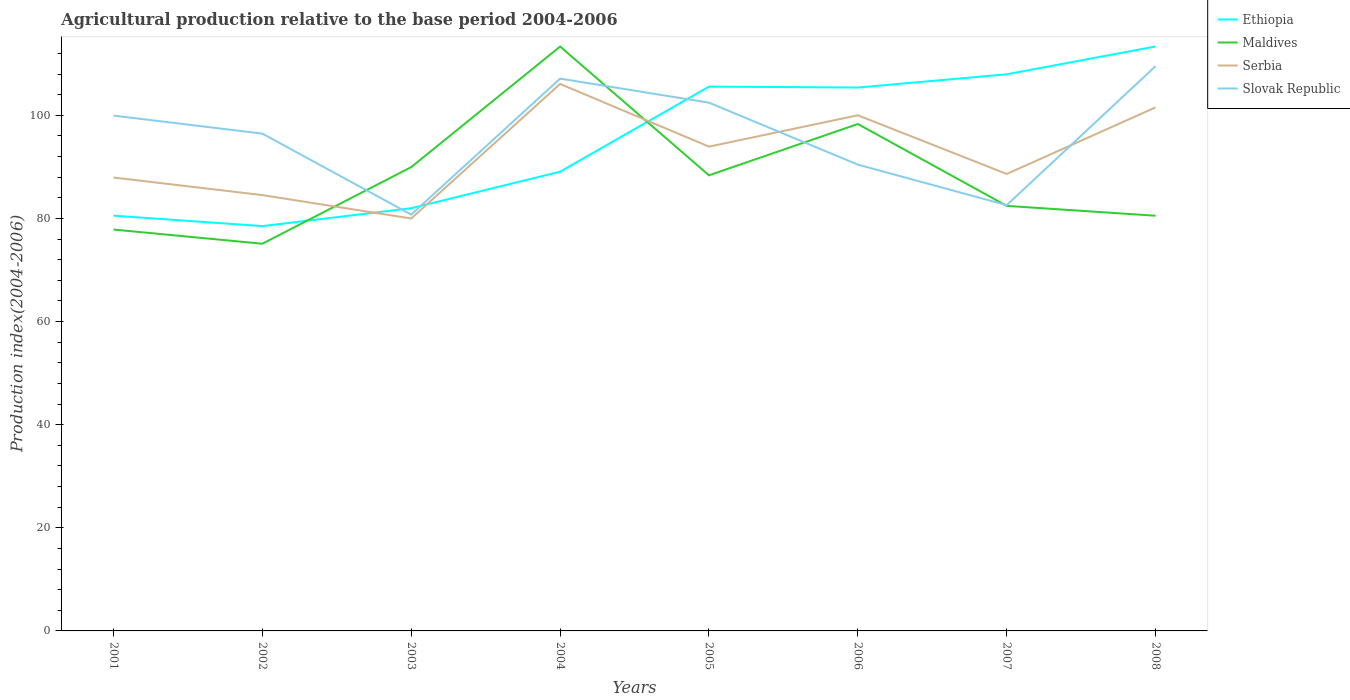How many different coloured lines are there?
Keep it short and to the point. 4. Across all years, what is the maximum agricultural production index in Slovak Republic?
Give a very brief answer. 80.74. What is the total agricultural production index in Ethiopia in the graph?
Keep it short and to the point. -24.29. What is the difference between the highest and the second highest agricultural production index in Ethiopia?
Provide a succinct answer. 34.84. Is the agricultural production index in Maldives strictly greater than the agricultural production index in Ethiopia over the years?
Make the answer very short. No. How many years are there in the graph?
Keep it short and to the point. 8. Does the graph contain grids?
Make the answer very short. No. Where does the legend appear in the graph?
Your response must be concise. Top right. How many legend labels are there?
Provide a short and direct response. 4. How are the legend labels stacked?
Make the answer very short. Vertical. What is the title of the graph?
Keep it short and to the point. Agricultural production relative to the base period 2004-2006. What is the label or title of the Y-axis?
Provide a short and direct response. Production index(2004-2006). What is the Production index(2004-2006) in Ethiopia in 2001?
Provide a short and direct response. 80.53. What is the Production index(2004-2006) in Maldives in 2001?
Offer a very short reply. 77.84. What is the Production index(2004-2006) in Serbia in 2001?
Give a very brief answer. 87.93. What is the Production index(2004-2006) of Slovak Republic in 2001?
Keep it short and to the point. 99.94. What is the Production index(2004-2006) in Ethiopia in 2002?
Keep it short and to the point. 78.51. What is the Production index(2004-2006) of Maldives in 2002?
Make the answer very short. 75.09. What is the Production index(2004-2006) of Serbia in 2002?
Make the answer very short. 84.52. What is the Production index(2004-2006) in Slovak Republic in 2002?
Make the answer very short. 96.44. What is the Production index(2004-2006) in Ethiopia in 2003?
Your answer should be compact. 81.98. What is the Production index(2004-2006) in Maldives in 2003?
Give a very brief answer. 89.95. What is the Production index(2004-2006) in Serbia in 2003?
Offer a very short reply. 79.98. What is the Production index(2004-2006) of Slovak Republic in 2003?
Keep it short and to the point. 80.74. What is the Production index(2004-2006) of Ethiopia in 2004?
Offer a terse response. 89.06. What is the Production index(2004-2006) of Maldives in 2004?
Your answer should be very brief. 113.33. What is the Production index(2004-2006) in Serbia in 2004?
Your answer should be compact. 106.08. What is the Production index(2004-2006) in Slovak Republic in 2004?
Your answer should be very brief. 107.11. What is the Production index(2004-2006) in Ethiopia in 2005?
Offer a very short reply. 105.56. What is the Production index(2004-2006) in Maldives in 2005?
Provide a short and direct response. 88.36. What is the Production index(2004-2006) of Serbia in 2005?
Your answer should be compact. 93.92. What is the Production index(2004-2006) in Slovak Republic in 2005?
Your answer should be compact. 102.45. What is the Production index(2004-2006) of Ethiopia in 2006?
Your answer should be compact. 105.38. What is the Production index(2004-2006) in Maldives in 2006?
Your response must be concise. 98.31. What is the Production index(2004-2006) in Slovak Republic in 2006?
Give a very brief answer. 90.43. What is the Production index(2004-2006) of Ethiopia in 2007?
Your response must be concise. 107.95. What is the Production index(2004-2006) of Maldives in 2007?
Keep it short and to the point. 82.43. What is the Production index(2004-2006) in Serbia in 2007?
Your response must be concise. 88.62. What is the Production index(2004-2006) in Slovak Republic in 2007?
Make the answer very short. 82.57. What is the Production index(2004-2006) of Ethiopia in 2008?
Give a very brief answer. 113.35. What is the Production index(2004-2006) of Maldives in 2008?
Give a very brief answer. 80.52. What is the Production index(2004-2006) in Serbia in 2008?
Provide a succinct answer. 101.53. What is the Production index(2004-2006) of Slovak Republic in 2008?
Ensure brevity in your answer.  109.53. Across all years, what is the maximum Production index(2004-2006) in Ethiopia?
Give a very brief answer. 113.35. Across all years, what is the maximum Production index(2004-2006) of Maldives?
Offer a very short reply. 113.33. Across all years, what is the maximum Production index(2004-2006) in Serbia?
Your response must be concise. 106.08. Across all years, what is the maximum Production index(2004-2006) of Slovak Republic?
Offer a very short reply. 109.53. Across all years, what is the minimum Production index(2004-2006) in Ethiopia?
Offer a terse response. 78.51. Across all years, what is the minimum Production index(2004-2006) in Maldives?
Make the answer very short. 75.09. Across all years, what is the minimum Production index(2004-2006) in Serbia?
Offer a very short reply. 79.98. Across all years, what is the minimum Production index(2004-2006) of Slovak Republic?
Your answer should be compact. 80.74. What is the total Production index(2004-2006) of Ethiopia in the graph?
Your answer should be very brief. 762.32. What is the total Production index(2004-2006) in Maldives in the graph?
Your answer should be very brief. 705.83. What is the total Production index(2004-2006) in Serbia in the graph?
Keep it short and to the point. 742.58. What is the total Production index(2004-2006) of Slovak Republic in the graph?
Give a very brief answer. 769.21. What is the difference between the Production index(2004-2006) in Ethiopia in 2001 and that in 2002?
Your answer should be compact. 2.02. What is the difference between the Production index(2004-2006) in Maldives in 2001 and that in 2002?
Offer a terse response. 2.75. What is the difference between the Production index(2004-2006) in Serbia in 2001 and that in 2002?
Your response must be concise. 3.41. What is the difference between the Production index(2004-2006) of Ethiopia in 2001 and that in 2003?
Give a very brief answer. -1.45. What is the difference between the Production index(2004-2006) in Maldives in 2001 and that in 2003?
Offer a very short reply. -12.11. What is the difference between the Production index(2004-2006) in Serbia in 2001 and that in 2003?
Your answer should be very brief. 7.95. What is the difference between the Production index(2004-2006) of Slovak Republic in 2001 and that in 2003?
Your answer should be very brief. 19.2. What is the difference between the Production index(2004-2006) in Ethiopia in 2001 and that in 2004?
Offer a terse response. -8.53. What is the difference between the Production index(2004-2006) in Maldives in 2001 and that in 2004?
Your answer should be compact. -35.49. What is the difference between the Production index(2004-2006) in Serbia in 2001 and that in 2004?
Your answer should be very brief. -18.15. What is the difference between the Production index(2004-2006) of Slovak Republic in 2001 and that in 2004?
Ensure brevity in your answer.  -7.17. What is the difference between the Production index(2004-2006) of Ethiopia in 2001 and that in 2005?
Offer a very short reply. -25.03. What is the difference between the Production index(2004-2006) of Maldives in 2001 and that in 2005?
Your answer should be compact. -10.52. What is the difference between the Production index(2004-2006) of Serbia in 2001 and that in 2005?
Keep it short and to the point. -5.99. What is the difference between the Production index(2004-2006) in Slovak Republic in 2001 and that in 2005?
Your answer should be compact. -2.51. What is the difference between the Production index(2004-2006) of Ethiopia in 2001 and that in 2006?
Your answer should be compact. -24.85. What is the difference between the Production index(2004-2006) of Maldives in 2001 and that in 2006?
Provide a succinct answer. -20.47. What is the difference between the Production index(2004-2006) in Serbia in 2001 and that in 2006?
Make the answer very short. -12.07. What is the difference between the Production index(2004-2006) of Slovak Republic in 2001 and that in 2006?
Your response must be concise. 9.51. What is the difference between the Production index(2004-2006) of Ethiopia in 2001 and that in 2007?
Provide a short and direct response. -27.42. What is the difference between the Production index(2004-2006) of Maldives in 2001 and that in 2007?
Give a very brief answer. -4.59. What is the difference between the Production index(2004-2006) in Serbia in 2001 and that in 2007?
Your response must be concise. -0.69. What is the difference between the Production index(2004-2006) in Slovak Republic in 2001 and that in 2007?
Provide a succinct answer. 17.37. What is the difference between the Production index(2004-2006) of Ethiopia in 2001 and that in 2008?
Provide a succinct answer. -32.82. What is the difference between the Production index(2004-2006) in Maldives in 2001 and that in 2008?
Ensure brevity in your answer.  -2.68. What is the difference between the Production index(2004-2006) in Serbia in 2001 and that in 2008?
Your answer should be compact. -13.6. What is the difference between the Production index(2004-2006) in Slovak Republic in 2001 and that in 2008?
Your answer should be compact. -9.59. What is the difference between the Production index(2004-2006) in Ethiopia in 2002 and that in 2003?
Your answer should be very brief. -3.47. What is the difference between the Production index(2004-2006) of Maldives in 2002 and that in 2003?
Give a very brief answer. -14.86. What is the difference between the Production index(2004-2006) in Serbia in 2002 and that in 2003?
Provide a succinct answer. 4.54. What is the difference between the Production index(2004-2006) of Slovak Republic in 2002 and that in 2003?
Your response must be concise. 15.7. What is the difference between the Production index(2004-2006) of Ethiopia in 2002 and that in 2004?
Provide a succinct answer. -10.55. What is the difference between the Production index(2004-2006) in Maldives in 2002 and that in 2004?
Give a very brief answer. -38.24. What is the difference between the Production index(2004-2006) in Serbia in 2002 and that in 2004?
Provide a succinct answer. -21.56. What is the difference between the Production index(2004-2006) of Slovak Republic in 2002 and that in 2004?
Your response must be concise. -10.67. What is the difference between the Production index(2004-2006) of Ethiopia in 2002 and that in 2005?
Ensure brevity in your answer.  -27.05. What is the difference between the Production index(2004-2006) in Maldives in 2002 and that in 2005?
Ensure brevity in your answer.  -13.27. What is the difference between the Production index(2004-2006) of Serbia in 2002 and that in 2005?
Make the answer very short. -9.4. What is the difference between the Production index(2004-2006) of Slovak Republic in 2002 and that in 2005?
Make the answer very short. -6.01. What is the difference between the Production index(2004-2006) of Ethiopia in 2002 and that in 2006?
Your answer should be compact. -26.87. What is the difference between the Production index(2004-2006) of Maldives in 2002 and that in 2006?
Offer a very short reply. -23.22. What is the difference between the Production index(2004-2006) in Serbia in 2002 and that in 2006?
Your response must be concise. -15.48. What is the difference between the Production index(2004-2006) in Slovak Republic in 2002 and that in 2006?
Your answer should be compact. 6.01. What is the difference between the Production index(2004-2006) in Ethiopia in 2002 and that in 2007?
Your answer should be very brief. -29.44. What is the difference between the Production index(2004-2006) of Maldives in 2002 and that in 2007?
Offer a terse response. -7.34. What is the difference between the Production index(2004-2006) in Serbia in 2002 and that in 2007?
Your response must be concise. -4.1. What is the difference between the Production index(2004-2006) of Slovak Republic in 2002 and that in 2007?
Make the answer very short. 13.87. What is the difference between the Production index(2004-2006) in Ethiopia in 2002 and that in 2008?
Offer a very short reply. -34.84. What is the difference between the Production index(2004-2006) in Maldives in 2002 and that in 2008?
Provide a short and direct response. -5.43. What is the difference between the Production index(2004-2006) in Serbia in 2002 and that in 2008?
Your answer should be compact. -17.01. What is the difference between the Production index(2004-2006) of Slovak Republic in 2002 and that in 2008?
Provide a succinct answer. -13.09. What is the difference between the Production index(2004-2006) of Ethiopia in 2003 and that in 2004?
Provide a succinct answer. -7.08. What is the difference between the Production index(2004-2006) of Maldives in 2003 and that in 2004?
Your answer should be very brief. -23.38. What is the difference between the Production index(2004-2006) in Serbia in 2003 and that in 2004?
Offer a terse response. -26.1. What is the difference between the Production index(2004-2006) in Slovak Republic in 2003 and that in 2004?
Ensure brevity in your answer.  -26.37. What is the difference between the Production index(2004-2006) of Ethiopia in 2003 and that in 2005?
Your answer should be compact. -23.58. What is the difference between the Production index(2004-2006) in Maldives in 2003 and that in 2005?
Ensure brevity in your answer.  1.59. What is the difference between the Production index(2004-2006) of Serbia in 2003 and that in 2005?
Make the answer very short. -13.94. What is the difference between the Production index(2004-2006) in Slovak Republic in 2003 and that in 2005?
Offer a very short reply. -21.71. What is the difference between the Production index(2004-2006) in Ethiopia in 2003 and that in 2006?
Make the answer very short. -23.4. What is the difference between the Production index(2004-2006) in Maldives in 2003 and that in 2006?
Offer a terse response. -8.36. What is the difference between the Production index(2004-2006) of Serbia in 2003 and that in 2006?
Give a very brief answer. -20.02. What is the difference between the Production index(2004-2006) in Slovak Republic in 2003 and that in 2006?
Offer a terse response. -9.69. What is the difference between the Production index(2004-2006) of Ethiopia in 2003 and that in 2007?
Your answer should be compact. -25.97. What is the difference between the Production index(2004-2006) in Maldives in 2003 and that in 2007?
Provide a succinct answer. 7.52. What is the difference between the Production index(2004-2006) of Serbia in 2003 and that in 2007?
Offer a terse response. -8.64. What is the difference between the Production index(2004-2006) of Slovak Republic in 2003 and that in 2007?
Provide a succinct answer. -1.83. What is the difference between the Production index(2004-2006) of Ethiopia in 2003 and that in 2008?
Ensure brevity in your answer.  -31.37. What is the difference between the Production index(2004-2006) in Maldives in 2003 and that in 2008?
Offer a terse response. 9.43. What is the difference between the Production index(2004-2006) in Serbia in 2003 and that in 2008?
Provide a succinct answer. -21.55. What is the difference between the Production index(2004-2006) in Slovak Republic in 2003 and that in 2008?
Your answer should be very brief. -28.79. What is the difference between the Production index(2004-2006) in Ethiopia in 2004 and that in 2005?
Make the answer very short. -16.5. What is the difference between the Production index(2004-2006) of Maldives in 2004 and that in 2005?
Ensure brevity in your answer.  24.97. What is the difference between the Production index(2004-2006) of Serbia in 2004 and that in 2005?
Give a very brief answer. 12.16. What is the difference between the Production index(2004-2006) of Slovak Republic in 2004 and that in 2005?
Ensure brevity in your answer.  4.66. What is the difference between the Production index(2004-2006) of Ethiopia in 2004 and that in 2006?
Your answer should be very brief. -16.32. What is the difference between the Production index(2004-2006) of Maldives in 2004 and that in 2006?
Make the answer very short. 15.02. What is the difference between the Production index(2004-2006) in Serbia in 2004 and that in 2006?
Provide a short and direct response. 6.08. What is the difference between the Production index(2004-2006) in Slovak Republic in 2004 and that in 2006?
Keep it short and to the point. 16.68. What is the difference between the Production index(2004-2006) of Ethiopia in 2004 and that in 2007?
Give a very brief answer. -18.89. What is the difference between the Production index(2004-2006) of Maldives in 2004 and that in 2007?
Your response must be concise. 30.9. What is the difference between the Production index(2004-2006) of Serbia in 2004 and that in 2007?
Ensure brevity in your answer.  17.46. What is the difference between the Production index(2004-2006) of Slovak Republic in 2004 and that in 2007?
Offer a very short reply. 24.54. What is the difference between the Production index(2004-2006) of Ethiopia in 2004 and that in 2008?
Provide a short and direct response. -24.29. What is the difference between the Production index(2004-2006) in Maldives in 2004 and that in 2008?
Offer a terse response. 32.81. What is the difference between the Production index(2004-2006) in Serbia in 2004 and that in 2008?
Give a very brief answer. 4.55. What is the difference between the Production index(2004-2006) in Slovak Republic in 2004 and that in 2008?
Ensure brevity in your answer.  -2.42. What is the difference between the Production index(2004-2006) of Ethiopia in 2005 and that in 2006?
Keep it short and to the point. 0.18. What is the difference between the Production index(2004-2006) in Maldives in 2005 and that in 2006?
Your answer should be compact. -9.95. What is the difference between the Production index(2004-2006) of Serbia in 2005 and that in 2006?
Your answer should be very brief. -6.08. What is the difference between the Production index(2004-2006) of Slovak Republic in 2005 and that in 2006?
Your answer should be compact. 12.02. What is the difference between the Production index(2004-2006) in Ethiopia in 2005 and that in 2007?
Make the answer very short. -2.39. What is the difference between the Production index(2004-2006) of Maldives in 2005 and that in 2007?
Your response must be concise. 5.93. What is the difference between the Production index(2004-2006) of Slovak Republic in 2005 and that in 2007?
Ensure brevity in your answer.  19.88. What is the difference between the Production index(2004-2006) in Ethiopia in 2005 and that in 2008?
Your answer should be very brief. -7.79. What is the difference between the Production index(2004-2006) of Maldives in 2005 and that in 2008?
Your answer should be very brief. 7.84. What is the difference between the Production index(2004-2006) of Serbia in 2005 and that in 2008?
Ensure brevity in your answer.  -7.61. What is the difference between the Production index(2004-2006) of Slovak Republic in 2005 and that in 2008?
Keep it short and to the point. -7.08. What is the difference between the Production index(2004-2006) in Ethiopia in 2006 and that in 2007?
Offer a terse response. -2.57. What is the difference between the Production index(2004-2006) in Maldives in 2006 and that in 2007?
Make the answer very short. 15.88. What is the difference between the Production index(2004-2006) of Serbia in 2006 and that in 2007?
Your answer should be compact. 11.38. What is the difference between the Production index(2004-2006) of Slovak Republic in 2006 and that in 2007?
Provide a succinct answer. 7.86. What is the difference between the Production index(2004-2006) in Ethiopia in 2006 and that in 2008?
Make the answer very short. -7.97. What is the difference between the Production index(2004-2006) in Maldives in 2006 and that in 2008?
Offer a terse response. 17.79. What is the difference between the Production index(2004-2006) in Serbia in 2006 and that in 2008?
Your answer should be very brief. -1.53. What is the difference between the Production index(2004-2006) in Slovak Republic in 2006 and that in 2008?
Keep it short and to the point. -19.1. What is the difference between the Production index(2004-2006) of Ethiopia in 2007 and that in 2008?
Offer a very short reply. -5.4. What is the difference between the Production index(2004-2006) of Maldives in 2007 and that in 2008?
Offer a terse response. 1.91. What is the difference between the Production index(2004-2006) in Serbia in 2007 and that in 2008?
Give a very brief answer. -12.91. What is the difference between the Production index(2004-2006) of Slovak Republic in 2007 and that in 2008?
Your answer should be very brief. -26.96. What is the difference between the Production index(2004-2006) of Ethiopia in 2001 and the Production index(2004-2006) of Maldives in 2002?
Ensure brevity in your answer.  5.44. What is the difference between the Production index(2004-2006) in Ethiopia in 2001 and the Production index(2004-2006) in Serbia in 2002?
Provide a short and direct response. -3.99. What is the difference between the Production index(2004-2006) of Ethiopia in 2001 and the Production index(2004-2006) of Slovak Republic in 2002?
Your answer should be very brief. -15.91. What is the difference between the Production index(2004-2006) of Maldives in 2001 and the Production index(2004-2006) of Serbia in 2002?
Your answer should be compact. -6.68. What is the difference between the Production index(2004-2006) of Maldives in 2001 and the Production index(2004-2006) of Slovak Republic in 2002?
Provide a succinct answer. -18.6. What is the difference between the Production index(2004-2006) in Serbia in 2001 and the Production index(2004-2006) in Slovak Republic in 2002?
Give a very brief answer. -8.51. What is the difference between the Production index(2004-2006) in Ethiopia in 2001 and the Production index(2004-2006) in Maldives in 2003?
Give a very brief answer. -9.42. What is the difference between the Production index(2004-2006) in Ethiopia in 2001 and the Production index(2004-2006) in Serbia in 2003?
Offer a very short reply. 0.55. What is the difference between the Production index(2004-2006) of Ethiopia in 2001 and the Production index(2004-2006) of Slovak Republic in 2003?
Your answer should be very brief. -0.21. What is the difference between the Production index(2004-2006) of Maldives in 2001 and the Production index(2004-2006) of Serbia in 2003?
Your answer should be very brief. -2.14. What is the difference between the Production index(2004-2006) in Maldives in 2001 and the Production index(2004-2006) in Slovak Republic in 2003?
Your answer should be compact. -2.9. What is the difference between the Production index(2004-2006) in Serbia in 2001 and the Production index(2004-2006) in Slovak Republic in 2003?
Provide a short and direct response. 7.19. What is the difference between the Production index(2004-2006) in Ethiopia in 2001 and the Production index(2004-2006) in Maldives in 2004?
Give a very brief answer. -32.8. What is the difference between the Production index(2004-2006) in Ethiopia in 2001 and the Production index(2004-2006) in Serbia in 2004?
Your answer should be very brief. -25.55. What is the difference between the Production index(2004-2006) of Ethiopia in 2001 and the Production index(2004-2006) of Slovak Republic in 2004?
Ensure brevity in your answer.  -26.58. What is the difference between the Production index(2004-2006) of Maldives in 2001 and the Production index(2004-2006) of Serbia in 2004?
Give a very brief answer. -28.24. What is the difference between the Production index(2004-2006) of Maldives in 2001 and the Production index(2004-2006) of Slovak Republic in 2004?
Your answer should be very brief. -29.27. What is the difference between the Production index(2004-2006) of Serbia in 2001 and the Production index(2004-2006) of Slovak Republic in 2004?
Keep it short and to the point. -19.18. What is the difference between the Production index(2004-2006) in Ethiopia in 2001 and the Production index(2004-2006) in Maldives in 2005?
Make the answer very short. -7.83. What is the difference between the Production index(2004-2006) in Ethiopia in 2001 and the Production index(2004-2006) in Serbia in 2005?
Give a very brief answer. -13.39. What is the difference between the Production index(2004-2006) of Ethiopia in 2001 and the Production index(2004-2006) of Slovak Republic in 2005?
Your answer should be compact. -21.92. What is the difference between the Production index(2004-2006) of Maldives in 2001 and the Production index(2004-2006) of Serbia in 2005?
Your response must be concise. -16.08. What is the difference between the Production index(2004-2006) in Maldives in 2001 and the Production index(2004-2006) in Slovak Republic in 2005?
Make the answer very short. -24.61. What is the difference between the Production index(2004-2006) in Serbia in 2001 and the Production index(2004-2006) in Slovak Republic in 2005?
Offer a terse response. -14.52. What is the difference between the Production index(2004-2006) in Ethiopia in 2001 and the Production index(2004-2006) in Maldives in 2006?
Give a very brief answer. -17.78. What is the difference between the Production index(2004-2006) of Ethiopia in 2001 and the Production index(2004-2006) of Serbia in 2006?
Provide a succinct answer. -19.47. What is the difference between the Production index(2004-2006) of Maldives in 2001 and the Production index(2004-2006) of Serbia in 2006?
Make the answer very short. -22.16. What is the difference between the Production index(2004-2006) of Maldives in 2001 and the Production index(2004-2006) of Slovak Republic in 2006?
Keep it short and to the point. -12.59. What is the difference between the Production index(2004-2006) in Serbia in 2001 and the Production index(2004-2006) in Slovak Republic in 2006?
Ensure brevity in your answer.  -2.5. What is the difference between the Production index(2004-2006) in Ethiopia in 2001 and the Production index(2004-2006) in Maldives in 2007?
Your answer should be very brief. -1.9. What is the difference between the Production index(2004-2006) of Ethiopia in 2001 and the Production index(2004-2006) of Serbia in 2007?
Give a very brief answer. -8.09. What is the difference between the Production index(2004-2006) in Ethiopia in 2001 and the Production index(2004-2006) in Slovak Republic in 2007?
Make the answer very short. -2.04. What is the difference between the Production index(2004-2006) of Maldives in 2001 and the Production index(2004-2006) of Serbia in 2007?
Your answer should be very brief. -10.78. What is the difference between the Production index(2004-2006) of Maldives in 2001 and the Production index(2004-2006) of Slovak Republic in 2007?
Offer a terse response. -4.73. What is the difference between the Production index(2004-2006) in Serbia in 2001 and the Production index(2004-2006) in Slovak Republic in 2007?
Make the answer very short. 5.36. What is the difference between the Production index(2004-2006) in Ethiopia in 2001 and the Production index(2004-2006) in Maldives in 2008?
Make the answer very short. 0.01. What is the difference between the Production index(2004-2006) in Ethiopia in 2001 and the Production index(2004-2006) in Serbia in 2008?
Your answer should be compact. -21. What is the difference between the Production index(2004-2006) of Ethiopia in 2001 and the Production index(2004-2006) of Slovak Republic in 2008?
Your answer should be very brief. -29. What is the difference between the Production index(2004-2006) of Maldives in 2001 and the Production index(2004-2006) of Serbia in 2008?
Offer a very short reply. -23.69. What is the difference between the Production index(2004-2006) of Maldives in 2001 and the Production index(2004-2006) of Slovak Republic in 2008?
Keep it short and to the point. -31.69. What is the difference between the Production index(2004-2006) in Serbia in 2001 and the Production index(2004-2006) in Slovak Republic in 2008?
Keep it short and to the point. -21.6. What is the difference between the Production index(2004-2006) of Ethiopia in 2002 and the Production index(2004-2006) of Maldives in 2003?
Provide a short and direct response. -11.44. What is the difference between the Production index(2004-2006) of Ethiopia in 2002 and the Production index(2004-2006) of Serbia in 2003?
Provide a short and direct response. -1.47. What is the difference between the Production index(2004-2006) of Ethiopia in 2002 and the Production index(2004-2006) of Slovak Republic in 2003?
Ensure brevity in your answer.  -2.23. What is the difference between the Production index(2004-2006) in Maldives in 2002 and the Production index(2004-2006) in Serbia in 2003?
Your answer should be very brief. -4.89. What is the difference between the Production index(2004-2006) in Maldives in 2002 and the Production index(2004-2006) in Slovak Republic in 2003?
Make the answer very short. -5.65. What is the difference between the Production index(2004-2006) in Serbia in 2002 and the Production index(2004-2006) in Slovak Republic in 2003?
Ensure brevity in your answer.  3.78. What is the difference between the Production index(2004-2006) in Ethiopia in 2002 and the Production index(2004-2006) in Maldives in 2004?
Provide a succinct answer. -34.82. What is the difference between the Production index(2004-2006) of Ethiopia in 2002 and the Production index(2004-2006) of Serbia in 2004?
Your answer should be compact. -27.57. What is the difference between the Production index(2004-2006) in Ethiopia in 2002 and the Production index(2004-2006) in Slovak Republic in 2004?
Offer a very short reply. -28.6. What is the difference between the Production index(2004-2006) of Maldives in 2002 and the Production index(2004-2006) of Serbia in 2004?
Give a very brief answer. -30.99. What is the difference between the Production index(2004-2006) of Maldives in 2002 and the Production index(2004-2006) of Slovak Republic in 2004?
Ensure brevity in your answer.  -32.02. What is the difference between the Production index(2004-2006) in Serbia in 2002 and the Production index(2004-2006) in Slovak Republic in 2004?
Give a very brief answer. -22.59. What is the difference between the Production index(2004-2006) of Ethiopia in 2002 and the Production index(2004-2006) of Maldives in 2005?
Your response must be concise. -9.85. What is the difference between the Production index(2004-2006) in Ethiopia in 2002 and the Production index(2004-2006) in Serbia in 2005?
Ensure brevity in your answer.  -15.41. What is the difference between the Production index(2004-2006) in Ethiopia in 2002 and the Production index(2004-2006) in Slovak Republic in 2005?
Your response must be concise. -23.94. What is the difference between the Production index(2004-2006) in Maldives in 2002 and the Production index(2004-2006) in Serbia in 2005?
Provide a short and direct response. -18.83. What is the difference between the Production index(2004-2006) in Maldives in 2002 and the Production index(2004-2006) in Slovak Republic in 2005?
Your answer should be very brief. -27.36. What is the difference between the Production index(2004-2006) in Serbia in 2002 and the Production index(2004-2006) in Slovak Republic in 2005?
Give a very brief answer. -17.93. What is the difference between the Production index(2004-2006) in Ethiopia in 2002 and the Production index(2004-2006) in Maldives in 2006?
Keep it short and to the point. -19.8. What is the difference between the Production index(2004-2006) in Ethiopia in 2002 and the Production index(2004-2006) in Serbia in 2006?
Offer a very short reply. -21.49. What is the difference between the Production index(2004-2006) of Ethiopia in 2002 and the Production index(2004-2006) of Slovak Republic in 2006?
Your response must be concise. -11.92. What is the difference between the Production index(2004-2006) of Maldives in 2002 and the Production index(2004-2006) of Serbia in 2006?
Your response must be concise. -24.91. What is the difference between the Production index(2004-2006) in Maldives in 2002 and the Production index(2004-2006) in Slovak Republic in 2006?
Make the answer very short. -15.34. What is the difference between the Production index(2004-2006) in Serbia in 2002 and the Production index(2004-2006) in Slovak Republic in 2006?
Ensure brevity in your answer.  -5.91. What is the difference between the Production index(2004-2006) of Ethiopia in 2002 and the Production index(2004-2006) of Maldives in 2007?
Your response must be concise. -3.92. What is the difference between the Production index(2004-2006) in Ethiopia in 2002 and the Production index(2004-2006) in Serbia in 2007?
Your answer should be very brief. -10.11. What is the difference between the Production index(2004-2006) of Ethiopia in 2002 and the Production index(2004-2006) of Slovak Republic in 2007?
Your answer should be compact. -4.06. What is the difference between the Production index(2004-2006) in Maldives in 2002 and the Production index(2004-2006) in Serbia in 2007?
Make the answer very short. -13.53. What is the difference between the Production index(2004-2006) of Maldives in 2002 and the Production index(2004-2006) of Slovak Republic in 2007?
Ensure brevity in your answer.  -7.48. What is the difference between the Production index(2004-2006) of Serbia in 2002 and the Production index(2004-2006) of Slovak Republic in 2007?
Keep it short and to the point. 1.95. What is the difference between the Production index(2004-2006) of Ethiopia in 2002 and the Production index(2004-2006) of Maldives in 2008?
Give a very brief answer. -2.01. What is the difference between the Production index(2004-2006) in Ethiopia in 2002 and the Production index(2004-2006) in Serbia in 2008?
Your answer should be compact. -23.02. What is the difference between the Production index(2004-2006) of Ethiopia in 2002 and the Production index(2004-2006) of Slovak Republic in 2008?
Make the answer very short. -31.02. What is the difference between the Production index(2004-2006) of Maldives in 2002 and the Production index(2004-2006) of Serbia in 2008?
Give a very brief answer. -26.44. What is the difference between the Production index(2004-2006) of Maldives in 2002 and the Production index(2004-2006) of Slovak Republic in 2008?
Provide a succinct answer. -34.44. What is the difference between the Production index(2004-2006) in Serbia in 2002 and the Production index(2004-2006) in Slovak Republic in 2008?
Give a very brief answer. -25.01. What is the difference between the Production index(2004-2006) of Ethiopia in 2003 and the Production index(2004-2006) of Maldives in 2004?
Your response must be concise. -31.35. What is the difference between the Production index(2004-2006) in Ethiopia in 2003 and the Production index(2004-2006) in Serbia in 2004?
Ensure brevity in your answer.  -24.1. What is the difference between the Production index(2004-2006) in Ethiopia in 2003 and the Production index(2004-2006) in Slovak Republic in 2004?
Offer a terse response. -25.13. What is the difference between the Production index(2004-2006) of Maldives in 2003 and the Production index(2004-2006) of Serbia in 2004?
Give a very brief answer. -16.13. What is the difference between the Production index(2004-2006) of Maldives in 2003 and the Production index(2004-2006) of Slovak Republic in 2004?
Keep it short and to the point. -17.16. What is the difference between the Production index(2004-2006) of Serbia in 2003 and the Production index(2004-2006) of Slovak Republic in 2004?
Keep it short and to the point. -27.13. What is the difference between the Production index(2004-2006) of Ethiopia in 2003 and the Production index(2004-2006) of Maldives in 2005?
Make the answer very short. -6.38. What is the difference between the Production index(2004-2006) of Ethiopia in 2003 and the Production index(2004-2006) of Serbia in 2005?
Provide a succinct answer. -11.94. What is the difference between the Production index(2004-2006) in Ethiopia in 2003 and the Production index(2004-2006) in Slovak Republic in 2005?
Give a very brief answer. -20.47. What is the difference between the Production index(2004-2006) in Maldives in 2003 and the Production index(2004-2006) in Serbia in 2005?
Your answer should be very brief. -3.97. What is the difference between the Production index(2004-2006) in Serbia in 2003 and the Production index(2004-2006) in Slovak Republic in 2005?
Your response must be concise. -22.47. What is the difference between the Production index(2004-2006) in Ethiopia in 2003 and the Production index(2004-2006) in Maldives in 2006?
Provide a succinct answer. -16.33. What is the difference between the Production index(2004-2006) in Ethiopia in 2003 and the Production index(2004-2006) in Serbia in 2006?
Your response must be concise. -18.02. What is the difference between the Production index(2004-2006) in Ethiopia in 2003 and the Production index(2004-2006) in Slovak Republic in 2006?
Give a very brief answer. -8.45. What is the difference between the Production index(2004-2006) of Maldives in 2003 and the Production index(2004-2006) of Serbia in 2006?
Your answer should be very brief. -10.05. What is the difference between the Production index(2004-2006) in Maldives in 2003 and the Production index(2004-2006) in Slovak Republic in 2006?
Make the answer very short. -0.48. What is the difference between the Production index(2004-2006) of Serbia in 2003 and the Production index(2004-2006) of Slovak Republic in 2006?
Your answer should be compact. -10.45. What is the difference between the Production index(2004-2006) in Ethiopia in 2003 and the Production index(2004-2006) in Maldives in 2007?
Keep it short and to the point. -0.45. What is the difference between the Production index(2004-2006) of Ethiopia in 2003 and the Production index(2004-2006) of Serbia in 2007?
Ensure brevity in your answer.  -6.64. What is the difference between the Production index(2004-2006) of Ethiopia in 2003 and the Production index(2004-2006) of Slovak Republic in 2007?
Keep it short and to the point. -0.59. What is the difference between the Production index(2004-2006) in Maldives in 2003 and the Production index(2004-2006) in Serbia in 2007?
Give a very brief answer. 1.33. What is the difference between the Production index(2004-2006) of Maldives in 2003 and the Production index(2004-2006) of Slovak Republic in 2007?
Keep it short and to the point. 7.38. What is the difference between the Production index(2004-2006) in Serbia in 2003 and the Production index(2004-2006) in Slovak Republic in 2007?
Make the answer very short. -2.59. What is the difference between the Production index(2004-2006) of Ethiopia in 2003 and the Production index(2004-2006) of Maldives in 2008?
Your answer should be very brief. 1.46. What is the difference between the Production index(2004-2006) in Ethiopia in 2003 and the Production index(2004-2006) in Serbia in 2008?
Your answer should be compact. -19.55. What is the difference between the Production index(2004-2006) in Ethiopia in 2003 and the Production index(2004-2006) in Slovak Republic in 2008?
Give a very brief answer. -27.55. What is the difference between the Production index(2004-2006) of Maldives in 2003 and the Production index(2004-2006) of Serbia in 2008?
Provide a short and direct response. -11.58. What is the difference between the Production index(2004-2006) of Maldives in 2003 and the Production index(2004-2006) of Slovak Republic in 2008?
Your answer should be very brief. -19.58. What is the difference between the Production index(2004-2006) in Serbia in 2003 and the Production index(2004-2006) in Slovak Republic in 2008?
Provide a short and direct response. -29.55. What is the difference between the Production index(2004-2006) of Ethiopia in 2004 and the Production index(2004-2006) of Serbia in 2005?
Give a very brief answer. -4.86. What is the difference between the Production index(2004-2006) in Ethiopia in 2004 and the Production index(2004-2006) in Slovak Republic in 2005?
Your answer should be very brief. -13.39. What is the difference between the Production index(2004-2006) in Maldives in 2004 and the Production index(2004-2006) in Serbia in 2005?
Give a very brief answer. 19.41. What is the difference between the Production index(2004-2006) in Maldives in 2004 and the Production index(2004-2006) in Slovak Republic in 2005?
Keep it short and to the point. 10.88. What is the difference between the Production index(2004-2006) in Serbia in 2004 and the Production index(2004-2006) in Slovak Republic in 2005?
Ensure brevity in your answer.  3.63. What is the difference between the Production index(2004-2006) of Ethiopia in 2004 and the Production index(2004-2006) of Maldives in 2006?
Offer a very short reply. -9.25. What is the difference between the Production index(2004-2006) in Ethiopia in 2004 and the Production index(2004-2006) in Serbia in 2006?
Make the answer very short. -10.94. What is the difference between the Production index(2004-2006) in Ethiopia in 2004 and the Production index(2004-2006) in Slovak Republic in 2006?
Keep it short and to the point. -1.37. What is the difference between the Production index(2004-2006) of Maldives in 2004 and the Production index(2004-2006) of Serbia in 2006?
Ensure brevity in your answer.  13.33. What is the difference between the Production index(2004-2006) of Maldives in 2004 and the Production index(2004-2006) of Slovak Republic in 2006?
Provide a short and direct response. 22.9. What is the difference between the Production index(2004-2006) in Serbia in 2004 and the Production index(2004-2006) in Slovak Republic in 2006?
Ensure brevity in your answer.  15.65. What is the difference between the Production index(2004-2006) in Ethiopia in 2004 and the Production index(2004-2006) in Maldives in 2007?
Provide a short and direct response. 6.63. What is the difference between the Production index(2004-2006) of Ethiopia in 2004 and the Production index(2004-2006) of Serbia in 2007?
Provide a short and direct response. 0.44. What is the difference between the Production index(2004-2006) in Ethiopia in 2004 and the Production index(2004-2006) in Slovak Republic in 2007?
Offer a terse response. 6.49. What is the difference between the Production index(2004-2006) in Maldives in 2004 and the Production index(2004-2006) in Serbia in 2007?
Provide a short and direct response. 24.71. What is the difference between the Production index(2004-2006) of Maldives in 2004 and the Production index(2004-2006) of Slovak Republic in 2007?
Provide a short and direct response. 30.76. What is the difference between the Production index(2004-2006) of Serbia in 2004 and the Production index(2004-2006) of Slovak Republic in 2007?
Provide a short and direct response. 23.51. What is the difference between the Production index(2004-2006) of Ethiopia in 2004 and the Production index(2004-2006) of Maldives in 2008?
Your answer should be compact. 8.54. What is the difference between the Production index(2004-2006) in Ethiopia in 2004 and the Production index(2004-2006) in Serbia in 2008?
Give a very brief answer. -12.47. What is the difference between the Production index(2004-2006) in Ethiopia in 2004 and the Production index(2004-2006) in Slovak Republic in 2008?
Offer a terse response. -20.47. What is the difference between the Production index(2004-2006) of Maldives in 2004 and the Production index(2004-2006) of Serbia in 2008?
Keep it short and to the point. 11.8. What is the difference between the Production index(2004-2006) of Maldives in 2004 and the Production index(2004-2006) of Slovak Republic in 2008?
Your answer should be very brief. 3.8. What is the difference between the Production index(2004-2006) in Serbia in 2004 and the Production index(2004-2006) in Slovak Republic in 2008?
Ensure brevity in your answer.  -3.45. What is the difference between the Production index(2004-2006) in Ethiopia in 2005 and the Production index(2004-2006) in Maldives in 2006?
Your response must be concise. 7.25. What is the difference between the Production index(2004-2006) of Ethiopia in 2005 and the Production index(2004-2006) of Serbia in 2006?
Provide a short and direct response. 5.56. What is the difference between the Production index(2004-2006) in Ethiopia in 2005 and the Production index(2004-2006) in Slovak Republic in 2006?
Your answer should be compact. 15.13. What is the difference between the Production index(2004-2006) of Maldives in 2005 and the Production index(2004-2006) of Serbia in 2006?
Provide a succinct answer. -11.64. What is the difference between the Production index(2004-2006) of Maldives in 2005 and the Production index(2004-2006) of Slovak Republic in 2006?
Provide a short and direct response. -2.07. What is the difference between the Production index(2004-2006) in Serbia in 2005 and the Production index(2004-2006) in Slovak Republic in 2006?
Offer a very short reply. 3.49. What is the difference between the Production index(2004-2006) in Ethiopia in 2005 and the Production index(2004-2006) in Maldives in 2007?
Offer a terse response. 23.13. What is the difference between the Production index(2004-2006) of Ethiopia in 2005 and the Production index(2004-2006) of Serbia in 2007?
Offer a very short reply. 16.94. What is the difference between the Production index(2004-2006) of Ethiopia in 2005 and the Production index(2004-2006) of Slovak Republic in 2007?
Provide a short and direct response. 22.99. What is the difference between the Production index(2004-2006) in Maldives in 2005 and the Production index(2004-2006) in Serbia in 2007?
Offer a very short reply. -0.26. What is the difference between the Production index(2004-2006) in Maldives in 2005 and the Production index(2004-2006) in Slovak Republic in 2007?
Your response must be concise. 5.79. What is the difference between the Production index(2004-2006) of Serbia in 2005 and the Production index(2004-2006) of Slovak Republic in 2007?
Make the answer very short. 11.35. What is the difference between the Production index(2004-2006) in Ethiopia in 2005 and the Production index(2004-2006) in Maldives in 2008?
Your answer should be compact. 25.04. What is the difference between the Production index(2004-2006) in Ethiopia in 2005 and the Production index(2004-2006) in Serbia in 2008?
Ensure brevity in your answer.  4.03. What is the difference between the Production index(2004-2006) of Ethiopia in 2005 and the Production index(2004-2006) of Slovak Republic in 2008?
Make the answer very short. -3.97. What is the difference between the Production index(2004-2006) in Maldives in 2005 and the Production index(2004-2006) in Serbia in 2008?
Your answer should be very brief. -13.17. What is the difference between the Production index(2004-2006) of Maldives in 2005 and the Production index(2004-2006) of Slovak Republic in 2008?
Ensure brevity in your answer.  -21.17. What is the difference between the Production index(2004-2006) of Serbia in 2005 and the Production index(2004-2006) of Slovak Republic in 2008?
Provide a succinct answer. -15.61. What is the difference between the Production index(2004-2006) in Ethiopia in 2006 and the Production index(2004-2006) in Maldives in 2007?
Make the answer very short. 22.95. What is the difference between the Production index(2004-2006) in Ethiopia in 2006 and the Production index(2004-2006) in Serbia in 2007?
Offer a terse response. 16.76. What is the difference between the Production index(2004-2006) of Ethiopia in 2006 and the Production index(2004-2006) of Slovak Republic in 2007?
Your answer should be compact. 22.81. What is the difference between the Production index(2004-2006) in Maldives in 2006 and the Production index(2004-2006) in Serbia in 2007?
Your response must be concise. 9.69. What is the difference between the Production index(2004-2006) in Maldives in 2006 and the Production index(2004-2006) in Slovak Republic in 2007?
Offer a terse response. 15.74. What is the difference between the Production index(2004-2006) of Serbia in 2006 and the Production index(2004-2006) of Slovak Republic in 2007?
Your answer should be compact. 17.43. What is the difference between the Production index(2004-2006) in Ethiopia in 2006 and the Production index(2004-2006) in Maldives in 2008?
Offer a terse response. 24.86. What is the difference between the Production index(2004-2006) in Ethiopia in 2006 and the Production index(2004-2006) in Serbia in 2008?
Keep it short and to the point. 3.85. What is the difference between the Production index(2004-2006) in Ethiopia in 2006 and the Production index(2004-2006) in Slovak Republic in 2008?
Offer a terse response. -4.15. What is the difference between the Production index(2004-2006) of Maldives in 2006 and the Production index(2004-2006) of Serbia in 2008?
Offer a very short reply. -3.22. What is the difference between the Production index(2004-2006) in Maldives in 2006 and the Production index(2004-2006) in Slovak Republic in 2008?
Ensure brevity in your answer.  -11.22. What is the difference between the Production index(2004-2006) of Serbia in 2006 and the Production index(2004-2006) of Slovak Republic in 2008?
Make the answer very short. -9.53. What is the difference between the Production index(2004-2006) in Ethiopia in 2007 and the Production index(2004-2006) in Maldives in 2008?
Ensure brevity in your answer.  27.43. What is the difference between the Production index(2004-2006) in Ethiopia in 2007 and the Production index(2004-2006) in Serbia in 2008?
Keep it short and to the point. 6.42. What is the difference between the Production index(2004-2006) of Ethiopia in 2007 and the Production index(2004-2006) of Slovak Republic in 2008?
Ensure brevity in your answer.  -1.58. What is the difference between the Production index(2004-2006) of Maldives in 2007 and the Production index(2004-2006) of Serbia in 2008?
Provide a short and direct response. -19.1. What is the difference between the Production index(2004-2006) in Maldives in 2007 and the Production index(2004-2006) in Slovak Republic in 2008?
Keep it short and to the point. -27.1. What is the difference between the Production index(2004-2006) of Serbia in 2007 and the Production index(2004-2006) of Slovak Republic in 2008?
Keep it short and to the point. -20.91. What is the average Production index(2004-2006) in Ethiopia per year?
Provide a short and direct response. 95.29. What is the average Production index(2004-2006) of Maldives per year?
Offer a very short reply. 88.23. What is the average Production index(2004-2006) in Serbia per year?
Make the answer very short. 92.82. What is the average Production index(2004-2006) in Slovak Republic per year?
Make the answer very short. 96.15. In the year 2001, what is the difference between the Production index(2004-2006) of Ethiopia and Production index(2004-2006) of Maldives?
Provide a short and direct response. 2.69. In the year 2001, what is the difference between the Production index(2004-2006) of Ethiopia and Production index(2004-2006) of Serbia?
Your response must be concise. -7.4. In the year 2001, what is the difference between the Production index(2004-2006) in Ethiopia and Production index(2004-2006) in Slovak Republic?
Make the answer very short. -19.41. In the year 2001, what is the difference between the Production index(2004-2006) of Maldives and Production index(2004-2006) of Serbia?
Provide a succinct answer. -10.09. In the year 2001, what is the difference between the Production index(2004-2006) in Maldives and Production index(2004-2006) in Slovak Republic?
Offer a very short reply. -22.1. In the year 2001, what is the difference between the Production index(2004-2006) in Serbia and Production index(2004-2006) in Slovak Republic?
Keep it short and to the point. -12.01. In the year 2002, what is the difference between the Production index(2004-2006) in Ethiopia and Production index(2004-2006) in Maldives?
Provide a succinct answer. 3.42. In the year 2002, what is the difference between the Production index(2004-2006) in Ethiopia and Production index(2004-2006) in Serbia?
Ensure brevity in your answer.  -6.01. In the year 2002, what is the difference between the Production index(2004-2006) in Ethiopia and Production index(2004-2006) in Slovak Republic?
Make the answer very short. -17.93. In the year 2002, what is the difference between the Production index(2004-2006) of Maldives and Production index(2004-2006) of Serbia?
Give a very brief answer. -9.43. In the year 2002, what is the difference between the Production index(2004-2006) of Maldives and Production index(2004-2006) of Slovak Republic?
Provide a succinct answer. -21.35. In the year 2002, what is the difference between the Production index(2004-2006) of Serbia and Production index(2004-2006) of Slovak Republic?
Offer a terse response. -11.92. In the year 2003, what is the difference between the Production index(2004-2006) in Ethiopia and Production index(2004-2006) in Maldives?
Provide a short and direct response. -7.97. In the year 2003, what is the difference between the Production index(2004-2006) of Ethiopia and Production index(2004-2006) of Serbia?
Your answer should be compact. 2. In the year 2003, what is the difference between the Production index(2004-2006) in Ethiopia and Production index(2004-2006) in Slovak Republic?
Offer a very short reply. 1.24. In the year 2003, what is the difference between the Production index(2004-2006) of Maldives and Production index(2004-2006) of Serbia?
Your answer should be very brief. 9.97. In the year 2003, what is the difference between the Production index(2004-2006) of Maldives and Production index(2004-2006) of Slovak Republic?
Keep it short and to the point. 9.21. In the year 2003, what is the difference between the Production index(2004-2006) of Serbia and Production index(2004-2006) of Slovak Republic?
Offer a very short reply. -0.76. In the year 2004, what is the difference between the Production index(2004-2006) of Ethiopia and Production index(2004-2006) of Maldives?
Your answer should be very brief. -24.27. In the year 2004, what is the difference between the Production index(2004-2006) of Ethiopia and Production index(2004-2006) of Serbia?
Ensure brevity in your answer.  -17.02. In the year 2004, what is the difference between the Production index(2004-2006) in Ethiopia and Production index(2004-2006) in Slovak Republic?
Make the answer very short. -18.05. In the year 2004, what is the difference between the Production index(2004-2006) in Maldives and Production index(2004-2006) in Serbia?
Ensure brevity in your answer.  7.25. In the year 2004, what is the difference between the Production index(2004-2006) in Maldives and Production index(2004-2006) in Slovak Republic?
Provide a short and direct response. 6.22. In the year 2004, what is the difference between the Production index(2004-2006) of Serbia and Production index(2004-2006) of Slovak Republic?
Your answer should be very brief. -1.03. In the year 2005, what is the difference between the Production index(2004-2006) in Ethiopia and Production index(2004-2006) in Maldives?
Make the answer very short. 17.2. In the year 2005, what is the difference between the Production index(2004-2006) in Ethiopia and Production index(2004-2006) in Serbia?
Offer a very short reply. 11.64. In the year 2005, what is the difference between the Production index(2004-2006) of Ethiopia and Production index(2004-2006) of Slovak Republic?
Keep it short and to the point. 3.11. In the year 2005, what is the difference between the Production index(2004-2006) of Maldives and Production index(2004-2006) of Serbia?
Keep it short and to the point. -5.56. In the year 2005, what is the difference between the Production index(2004-2006) of Maldives and Production index(2004-2006) of Slovak Republic?
Give a very brief answer. -14.09. In the year 2005, what is the difference between the Production index(2004-2006) in Serbia and Production index(2004-2006) in Slovak Republic?
Your answer should be compact. -8.53. In the year 2006, what is the difference between the Production index(2004-2006) of Ethiopia and Production index(2004-2006) of Maldives?
Ensure brevity in your answer.  7.07. In the year 2006, what is the difference between the Production index(2004-2006) of Ethiopia and Production index(2004-2006) of Serbia?
Offer a very short reply. 5.38. In the year 2006, what is the difference between the Production index(2004-2006) in Ethiopia and Production index(2004-2006) in Slovak Republic?
Offer a terse response. 14.95. In the year 2006, what is the difference between the Production index(2004-2006) in Maldives and Production index(2004-2006) in Serbia?
Give a very brief answer. -1.69. In the year 2006, what is the difference between the Production index(2004-2006) in Maldives and Production index(2004-2006) in Slovak Republic?
Offer a terse response. 7.88. In the year 2006, what is the difference between the Production index(2004-2006) in Serbia and Production index(2004-2006) in Slovak Republic?
Keep it short and to the point. 9.57. In the year 2007, what is the difference between the Production index(2004-2006) of Ethiopia and Production index(2004-2006) of Maldives?
Make the answer very short. 25.52. In the year 2007, what is the difference between the Production index(2004-2006) of Ethiopia and Production index(2004-2006) of Serbia?
Provide a short and direct response. 19.33. In the year 2007, what is the difference between the Production index(2004-2006) in Ethiopia and Production index(2004-2006) in Slovak Republic?
Provide a succinct answer. 25.38. In the year 2007, what is the difference between the Production index(2004-2006) in Maldives and Production index(2004-2006) in Serbia?
Provide a succinct answer. -6.19. In the year 2007, what is the difference between the Production index(2004-2006) in Maldives and Production index(2004-2006) in Slovak Republic?
Make the answer very short. -0.14. In the year 2007, what is the difference between the Production index(2004-2006) of Serbia and Production index(2004-2006) of Slovak Republic?
Your answer should be very brief. 6.05. In the year 2008, what is the difference between the Production index(2004-2006) of Ethiopia and Production index(2004-2006) of Maldives?
Your answer should be compact. 32.83. In the year 2008, what is the difference between the Production index(2004-2006) in Ethiopia and Production index(2004-2006) in Serbia?
Keep it short and to the point. 11.82. In the year 2008, what is the difference between the Production index(2004-2006) of Ethiopia and Production index(2004-2006) of Slovak Republic?
Give a very brief answer. 3.82. In the year 2008, what is the difference between the Production index(2004-2006) in Maldives and Production index(2004-2006) in Serbia?
Keep it short and to the point. -21.01. In the year 2008, what is the difference between the Production index(2004-2006) in Maldives and Production index(2004-2006) in Slovak Republic?
Your response must be concise. -29.01. In the year 2008, what is the difference between the Production index(2004-2006) in Serbia and Production index(2004-2006) in Slovak Republic?
Give a very brief answer. -8. What is the ratio of the Production index(2004-2006) of Ethiopia in 2001 to that in 2002?
Keep it short and to the point. 1.03. What is the ratio of the Production index(2004-2006) in Maldives in 2001 to that in 2002?
Ensure brevity in your answer.  1.04. What is the ratio of the Production index(2004-2006) of Serbia in 2001 to that in 2002?
Keep it short and to the point. 1.04. What is the ratio of the Production index(2004-2006) in Slovak Republic in 2001 to that in 2002?
Provide a succinct answer. 1.04. What is the ratio of the Production index(2004-2006) in Ethiopia in 2001 to that in 2003?
Your response must be concise. 0.98. What is the ratio of the Production index(2004-2006) of Maldives in 2001 to that in 2003?
Your response must be concise. 0.87. What is the ratio of the Production index(2004-2006) of Serbia in 2001 to that in 2003?
Provide a succinct answer. 1.1. What is the ratio of the Production index(2004-2006) in Slovak Republic in 2001 to that in 2003?
Your answer should be compact. 1.24. What is the ratio of the Production index(2004-2006) in Ethiopia in 2001 to that in 2004?
Provide a succinct answer. 0.9. What is the ratio of the Production index(2004-2006) in Maldives in 2001 to that in 2004?
Give a very brief answer. 0.69. What is the ratio of the Production index(2004-2006) of Serbia in 2001 to that in 2004?
Your answer should be compact. 0.83. What is the ratio of the Production index(2004-2006) of Slovak Republic in 2001 to that in 2004?
Your response must be concise. 0.93. What is the ratio of the Production index(2004-2006) in Ethiopia in 2001 to that in 2005?
Your answer should be very brief. 0.76. What is the ratio of the Production index(2004-2006) of Maldives in 2001 to that in 2005?
Your answer should be compact. 0.88. What is the ratio of the Production index(2004-2006) of Serbia in 2001 to that in 2005?
Provide a short and direct response. 0.94. What is the ratio of the Production index(2004-2006) of Slovak Republic in 2001 to that in 2005?
Your response must be concise. 0.98. What is the ratio of the Production index(2004-2006) in Ethiopia in 2001 to that in 2006?
Keep it short and to the point. 0.76. What is the ratio of the Production index(2004-2006) in Maldives in 2001 to that in 2006?
Keep it short and to the point. 0.79. What is the ratio of the Production index(2004-2006) of Serbia in 2001 to that in 2006?
Ensure brevity in your answer.  0.88. What is the ratio of the Production index(2004-2006) of Slovak Republic in 2001 to that in 2006?
Make the answer very short. 1.11. What is the ratio of the Production index(2004-2006) of Ethiopia in 2001 to that in 2007?
Your answer should be compact. 0.75. What is the ratio of the Production index(2004-2006) in Maldives in 2001 to that in 2007?
Your answer should be very brief. 0.94. What is the ratio of the Production index(2004-2006) of Slovak Republic in 2001 to that in 2007?
Keep it short and to the point. 1.21. What is the ratio of the Production index(2004-2006) of Ethiopia in 2001 to that in 2008?
Your answer should be compact. 0.71. What is the ratio of the Production index(2004-2006) of Maldives in 2001 to that in 2008?
Provide a short and direct response. 0.97. What is the ratio of the Production index(2004-2006) in Serbia in 2001 to that in 2008?
Your response must be concise. 0.87. What is the ratio of the Production index(2004-2006) in Slovak Republic in 2001 to that in 2008?
Offer a very short reply. 0.91. What is the ratio of the Production index(2004-2006) of Ethiopia in 2002 to that in 2003?
Your response must be concise. 0.96. What is the ratio of the Production index(2004-2006) of Maldives in 2002 to that in 2003?
Give a very brief answer. 0.83. What is the ratio of the Production index(2004-2006) in Serbia in 2002 to that in 2003?
Provide a short and direct response. 1.06. What is the ratio of the Production index(2004-2006) of Slovak Republic in 2002 to that in 2003?
Keep it short and to the point. 1.19. What is the ratio of the Production index(2004-2006) of Ethiopia in 2002 to that in 2004?
Your response must be concise. 0.88. What is the ratio of the Production index(2004-2006) in Maldives in 2002 to that in 2004?
Your answer should be very brief. 0.66. What is the ratio of the Production index(2004-2006) in Serbia in 2002 to that in 2004?
Give a very brief answer. 0.8. What is the ratio of the Production index(2004-2006) of Slovak Republic in 2002 to that in 2004?
Keep it short and to the point. 0.9. What is the ratio of the Production index(2004-2006) in Ethiopia in 2002 to that in 2005?
Make the answer very short. 0.74. What is the ratio of the Production index(2004-2006) in Maldives in 2002 to that in 2005?
Keep it short and to the point. 0.85. What is the ratio of the Production index(2004-2006) of Serbia in 2002 to that in 2005?
Provide a short and direct response. 0.9. What is the ratio of the Production index(2004-2006) in Slovak Republic in 2002 to that in 2005?
Keep it short and to the point. 0.94. What is the ratio of the Production index(2004-2006) in Ethiopia in 2002 to that in 2006?
Give a very brief answer. 0.74. What is the ratio of the Production index(2004-2006) in Maldives in 2002 to that in 2006?
Your answer should be very brief. 0.76. What is the ratio of the Production index(2004-2006) of Serbia in 2002 to that in 2006?
Offer a terse response. 0.85. What is the ratio of the Production index(2004-2006) of Slovak Republic in 2002 to that in 2006?
Provide a short and direct response. 1.07. What is the ratio of the Production index(2004-2006) in Ethiopia in 2002 to that in 2007?
Your answer should be compact. 0.73. What is the ratio of the Production index(2004-2006) in Maldives in 2002 to that in 2007?
Offer a very short reply. 0.91. What is the ratio of the Production index(2004-2006) of Serbia in 2002 to that in 2007?
Your answer should be compact. 0.95. What is the ratio of the Production index(2004-2006) of Slovak Republic in 2002 to that in 2007?
Your answer should be very brief. 1.17. What is the ratio of the Production index(2004-2006) in Ethiopia in 2002 to that in 2008?
Your answer should be compact. 0.69. What is the ratio of the Production index(2004-2006) of Maldives in 2002 to that in 2008?
Your answer should be very brief. 0.93. What is the ratio of the Production index(2004-2006) of Serbia in 2002 to that in 2008?
Your answer should be very brief. 0.83. What is the ratio of the Production index(2004-2006) of Slovak Republic in 2002 to that in 2008?
Provide a succinct answer. 0.88. What is the ratio of the Production index(2004-2006) of Ethiopia in 2003 to that in 2004?
Your answer should be very brief. 0.92. What is the ratio of the Production index(2004-2006) of Maldives in 2003 to that in 2004?
Give a very brief answer. 0.79. What is the ratio of the Production index(2004-2006) of Serbia in 2003 to that in 2004?
Offer a terse response. 0.75. What is the ratio of the Production index(2004-2006) of Slovak Republic in 2003 to that in 2004?
Your answer should be compact. 0.75. What is the ratio of the Production index(2004-2006) in Ethiopia in 2003 to that in 2005?
Your answer should be compact. 0.78. What is the ratio of the Production index(2004-2006) of Maldives in 2003 to that in 2005?
Make the answer very short. 1.02. What is the ratio of the Production index(2004-2006) of Serbia in 2003 to that in 2005?
Your response must be concise. 0.85. What is the ratio of the Production index(2004-2006) of Slovak Republic in 2003 to that in 2005?
Provide a succinct answer. 0.79. What is the ratio of the Production index(2004-2006) of Ethiopia in 2003 to that in 2006?
Give a very brief answer. 0.78. What is the ratio of the Production index(2004-2006) of Maldives in 2003 to that in 2006?
Your answer should be very brief. 0.92. What is the ratio of the Production index(2004-2006) in Serbia in 2003 to that in 2006?
Give a very brief answer. 0.8. What is the ratio of the Production index(2004-2006) in Slovak Republic in 2003 to that in 2006?
Provide a succinct answer. 0.89. What is the ratio of the Production index(2004-2006) of Ethiopia in 2003 to that in 2007?
Your answer should be compact. 0.76. What is the ratio of the Production index(2004-2006) in Maldives in 2003 to that in 2007?
Your answer should be compact. 1.09. What is the ratio of the Production index(2004-2006) of Serbia in 2003 to that in 2007?
Your answer should be very brief. 0.9. What is the ratio of the Production index(2004-2006) of Slovak Republic in 2003 to that in 2007?
Your answer should be compact. 0.98. What is the ratio of the Production index(2004-2006) of Ethiopia in 2003 to that in 2008?
Your answer should be compact. 0.72. What is the ratio of the Production index(2004-2006) of Maldives in 2003 to that in 2008?
Offer a terse response. 1.12. What is the ratio of the Production index(2004-2006) in Serbia in 2003 to that in 2008?
Keep it short and to the point. 0.79. What is the ratio of the Production index(2004-2006) in Slovak Republic in 2003 to that in 2008?
Your answer should be compact. 0.74. What is the ratio of the Production index(2004-2006) of Ethiopia in 2004 to that in 2005?
Your response must be concise. 0.84. What is the ratio of the Production index(2004-2006) in Maldives in 2004 to that in 2005?
Give a very brief answer. 1.28. What is the ratio of the Production index(2004-2006) of Serbia in 2004 to that in 2005?
Your answer should be very brief. 1.13. What is the ratio of the Production index(2004-2006) in Slovak Republic in 2004 to that in 2005?
Ensure brevity in your answer.  1.05. What is the ratio of the Production index(2004-2006) of Ethiopia in 2004 to that in 2006?
Provide a short and direct response. 0.85. What is the ratio of the Production index(2004-2006) of Maldives in 2004 to that in 2006?
Your answer should be compact. 1.15. What is the ratio of the Production index(2004-2006) in Serbia in 2004 to that in 2006?
Keep it short and to the point. 1.06. What is the ratio of the Production index(2004-2006) of Slovak Republic in 2004 to that in 2006?
Your response must be concise. 1.18. What is the ratio of the Production index(2004-2006) in Ethiopia in 2004 to that in 2007?
Your response must be concise. 0.82. What is the ratio of the Production index(2004-2006) in Maldives in 2004 to that in 2007?
Your response must be concise. 1.37. What is the ratio of the Production index(2004-2006) in Serbia in 2004 to that in 2007?
Your answer should be compact. 1.2. What is the ratio of the Production index(2004-2006) in Slovak Republic in 2004 to that in 2007?
Your answer should be compact. 1.3. What is the ratio of the Production index(2004-2006) of Ethiopia in 2004 to that in 2008?
Ensure brevity in your answer.  0.79. What is the ratio of the Production index(2004-2006) of Maldives in 2004 to that in 2008?
Your answer should be very brief. 1.41. What is the ratio of the Production index(2004-2006) of Serbia in 2004 to that in 2008?
Offer a terse response. 1.04. What is the ratio of the Production index(2004-2006) in Slovak Republic in 2004 to that in 2008?
Your answer should be compact. 0.98. What is the ratio of the Production index(2004-2006) in Maldives in 2005 to that in 2006?
Your response must be concise. 0.9. What is the ratio of the Production index(2004-2006) in Serbia in 2005 to that in 2006?
Provide a short and direct response. 0.94. What is the ratio of the Production index(2004-2006) in Slovak Republic in 2005 to that in 2006?
Your response must be concise. 1.13. What is the ratio of the Production index(2004-2006) in Ethiopia in 2005 to that in 2007?
Offer a terse response. 0.98. What is the ratio of the Production index(2004-2006) of Maldives in 2005 to that in 2007?
Give a very brief answer. 1.07. What is the ratio of the Production index(2004-2006) of Serbia in 2005 to that in 2007?
Offer a terse response. 1.06. What is the ratio of the Production index(2004-2006) in Slovak Republic in 2005 to that in 2007?
Provide a short and direct response. 1.24. What is the ratio of the Production index(2004-2006) in Ethiopia in 2005 to that in 2008?
Your response must be concise. 0.93. What is the ratio of the Production index(2004-2006) of Maldives in 2005 to that in 2008?
Ensure brevity in your answer.  1.1. What is the ratio of the Production index(2004-2006) of Serbia in 2005 to that in 2008?
Keep it short and to the point. 0.93. What is the ratio of the Production index(2004-2006) of Slovak Republic in 2005 to that in 2008?
Keep it short and to the point. 0.94. What is the ratio of the Production index(2004-2006) in Ethiopia in 2006 to that in 2007?
Ensure brevity in your answer.  0.98. What is the ratio of the Production index(2004-2006) of Maldives in 2006 to that in 2007?
Your answer should be very brief. 1.19. What is the ratio of the Production index(2004-2006) of Serbia in 2006 to that in 2007?
Make the answer very short. 1.13. What is the ratio of the Production index(2004-2006) in Slovak Republic in 2006 to that in 2007?
Your answer should be very brief. 1.1. What is the ratio of the Production index(2004-2006) of Ethiopia in 2006 to that in 2008?
Your answer should be compact. 0.93. What is the ratio of the Production index(2004-2006) of Maldives in 2006 to that in 2008?
Offer a terse response. 1.22. What is the ratio of the Production index(2004-2006) of Serbia in 2006 to that in 2008?
Your answer should be compact. 0.98. What is the ratio of the Production index(2004-2006) in Slovak Republic in 2006 to that in 2008?
Give a very brief answer. 0.83. What is the ratio of the Production index(2004-2006) in Maldives in 2007 to that in 2008?
Give a very brief answer. 1.02. What is the ratio of the Production index(2004-2006) of Serbia in 2007 to that in 2008?
Give a very brief answer. 0.87. What is the ratio of the Production index(2004-2006) in Slovak Republic in 2007 to that in 2008?
Offer a very short reply. 0.75. What is the difference between the highest and the second highest Production index(2004-2006) in Ethiopia?
Provide a short and direct response. 5.4. What is the difference between the highest and the second highest Production index(2004-2006) in Maldives?
Offer a terse response. 15.02. What is the difference between the highest and the second highest Production index(2004-2006) of Serbia?
Give a very brief answer. 4.55. What is the difference between the highest and the second highest Production index(2004-2006) of Slovak Republic?
Offer a very short reply. 2.42. What is the difference between the highest and the lowest Production index(2004-2006) of Ethiopia?
Your answer should be very brief. 34.84. What is the difference between the highest and the lowest Production index(2004-2006) in Maldives?
Keep it short and to the point. 38.24. What is the difference between the highest and the lowest Production index(2004-2006) in Serbia?
Keep it short and to the point. 26.1. What is the difference between the highest and the lowest Production index(2004-2006) in Slovak Republic?
Offer a terse response. 28.79. 